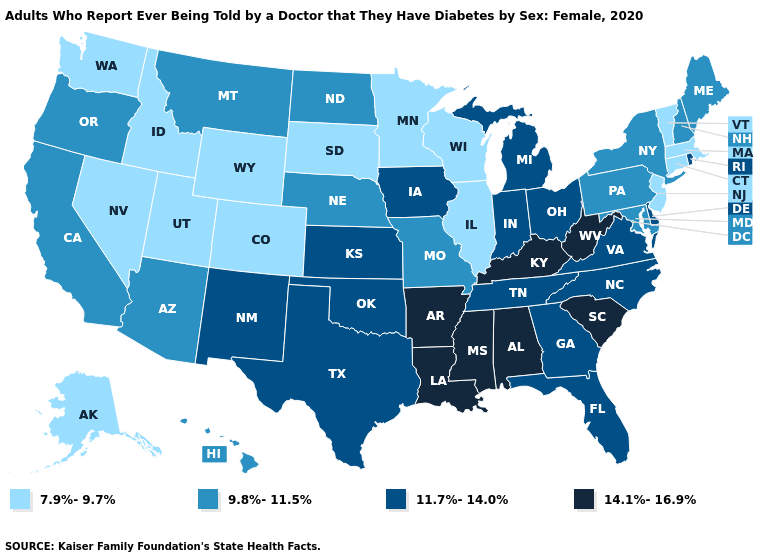Is the legend a continuous bar?
Keep it brief. No. What is the lowest value in the South?
Keep it brief. 9.8%-11.5%. Name the states that have a value in the range 14.1%-16.9%?
Short answer required. Alabama, Arkansas, Kentucky, Louisiana, Mississippi, South Carolina, West Virginia. Name the states that have a value in the range 7.9%-9.7%?
Concise answer only. Alaska, Colorado, Connecticut, Idaho, Illinois, Massachusetts, Minnesota, Nevada, New Jersey, South Dakota, Utah, Vermont, Washington, Wisconsin, Wyoming. What is the value of Mississippi?
Be succinct. 14.1%-16.9%. Name the states that have a value in the range 11.7%-14.0%?
Be succinct. Delaware, Florida, Georgia, Indiana, Iowa, Kansas, Michigan, New Mexico, North Carolina, Ohio, Oklahoma, Rhode Island, Tennessee, Texas, Virginia. Among the states that border Massachusetts , which have the highest value?
Short answer required. Rhode Island. Does Georgia have a higher value than Indiana?
Answer briefly. No. How many symbols are there in the legend?
Concise answer only. 4. Does Indiana have a higher value than Idaho?
Keep it brief. Yes. Does Oregon have the highest value in the West?
Short answer required. No. Which states have the lowest value in the USA?
Short answer required. Alaska, Colorado, Connecticut, Idaho, Illinois, Massachusetts, Minnesota, Nevada, New Jersey, South Dakota, Utah, Vermont, Washington, Wisconsin, Wyoming. Does California have the same value as Maryland?
Quick response, please. Yes. Name the states that have a value in the range 14.1%-16.9%?
Answer briefly. Alabama, Arkansas, Kentucky, Louisiana, Mississippi, South Carolina, West Virginia. 